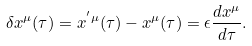<formula> <loc_0><loc_0><loc_500><loc_500>\delta x ^ { \mu } ( \tau ) = x ^ { ^ { \prime } \mu } ( \tau ) - x ^ { \mu } ( \tau ) = \epsilon \frac { d x ^ { \mu } } { d \tau } .</formula> 